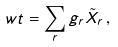Convert formula to latex. <formula><loc_0><loc_0><loc_500><loc_500>\ w t = \sum _ { r } g _ { r } \tilde { X } _ { r } \, ,</formula> 